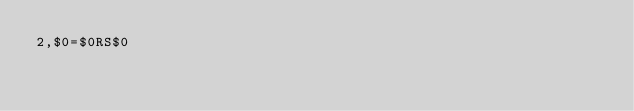Convert code to text. <code><loc_0><loc_0><loc_500><loc_500><_Awk_>2,$0=$0RS$0</code> 